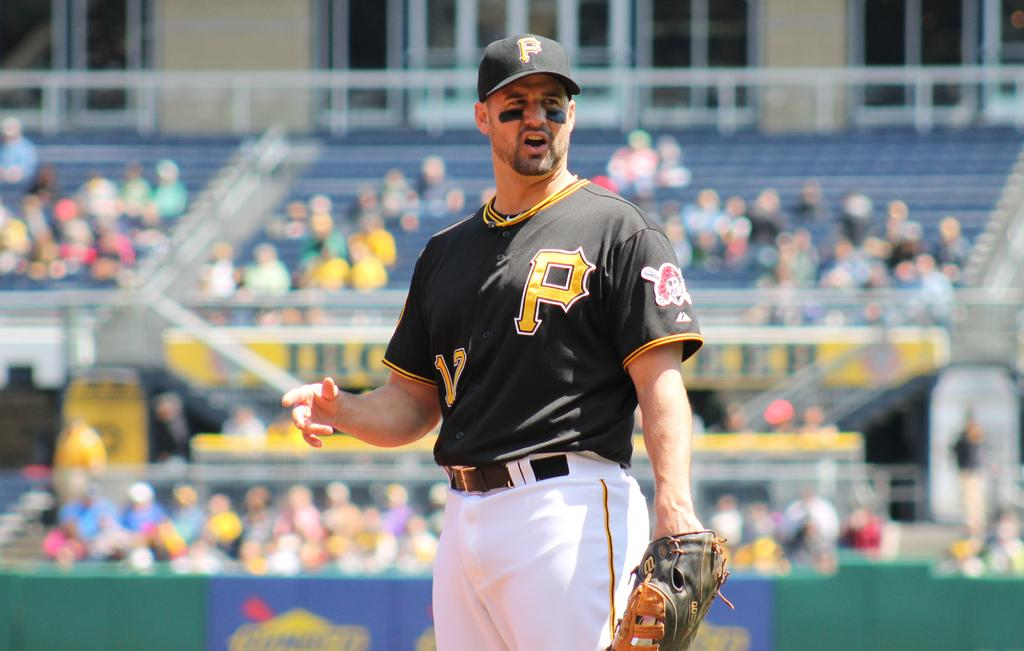<image>
Describe the image concisely. the letter P is on the jersey of the player 